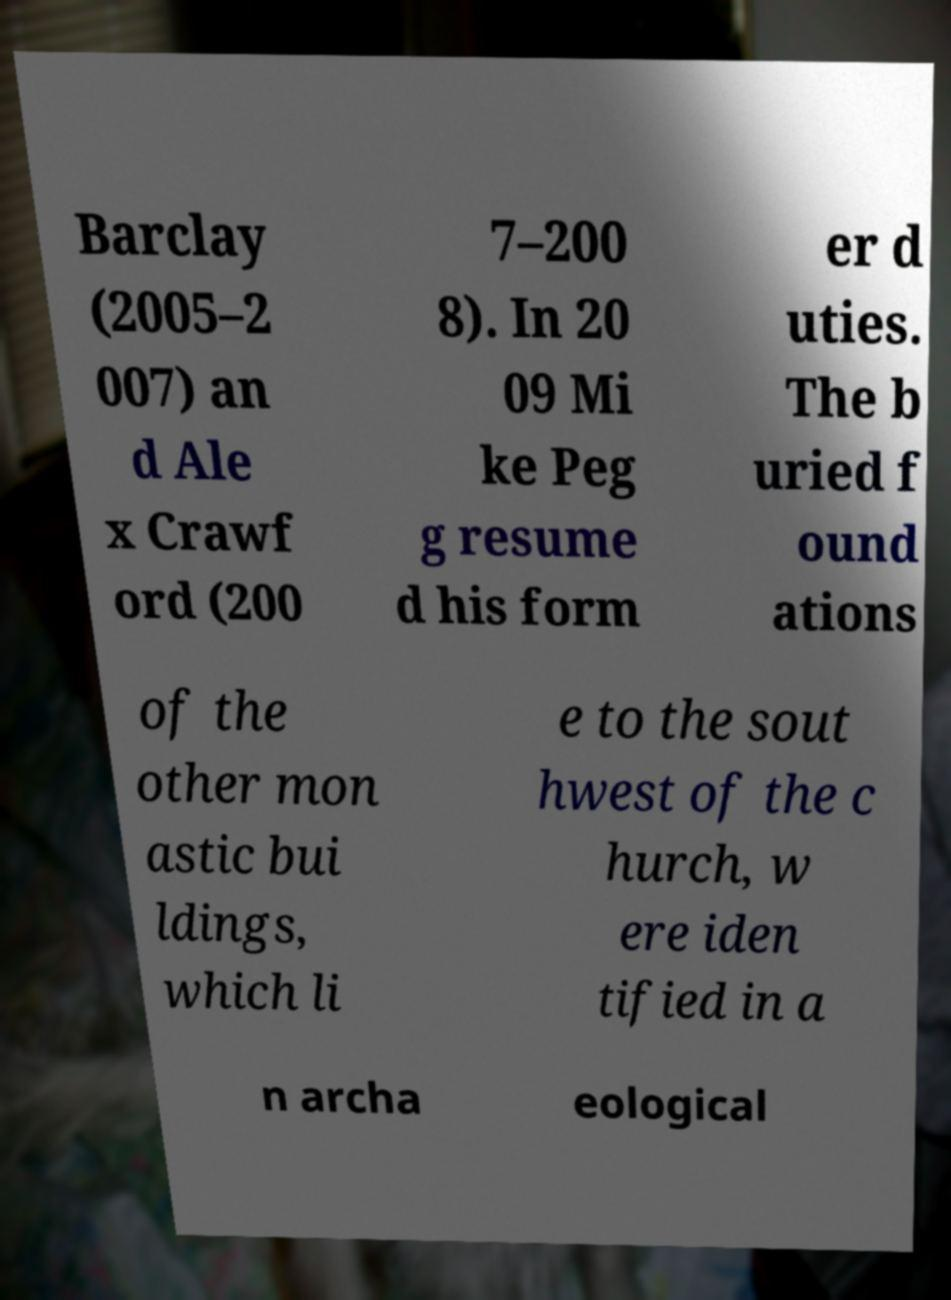I need the written content from this picture converted into text. Can you do that? Barclay (2005–2 007) an d Ale x Crawf ord (200 7–200 8). In 20 09 Mi ke Peg g resume d his form er d uties. The b uried f ound ations of the other mon astic bui ldings, which li e to the sout hwest of the c hurch, w ere iden tified in a n archa eological 